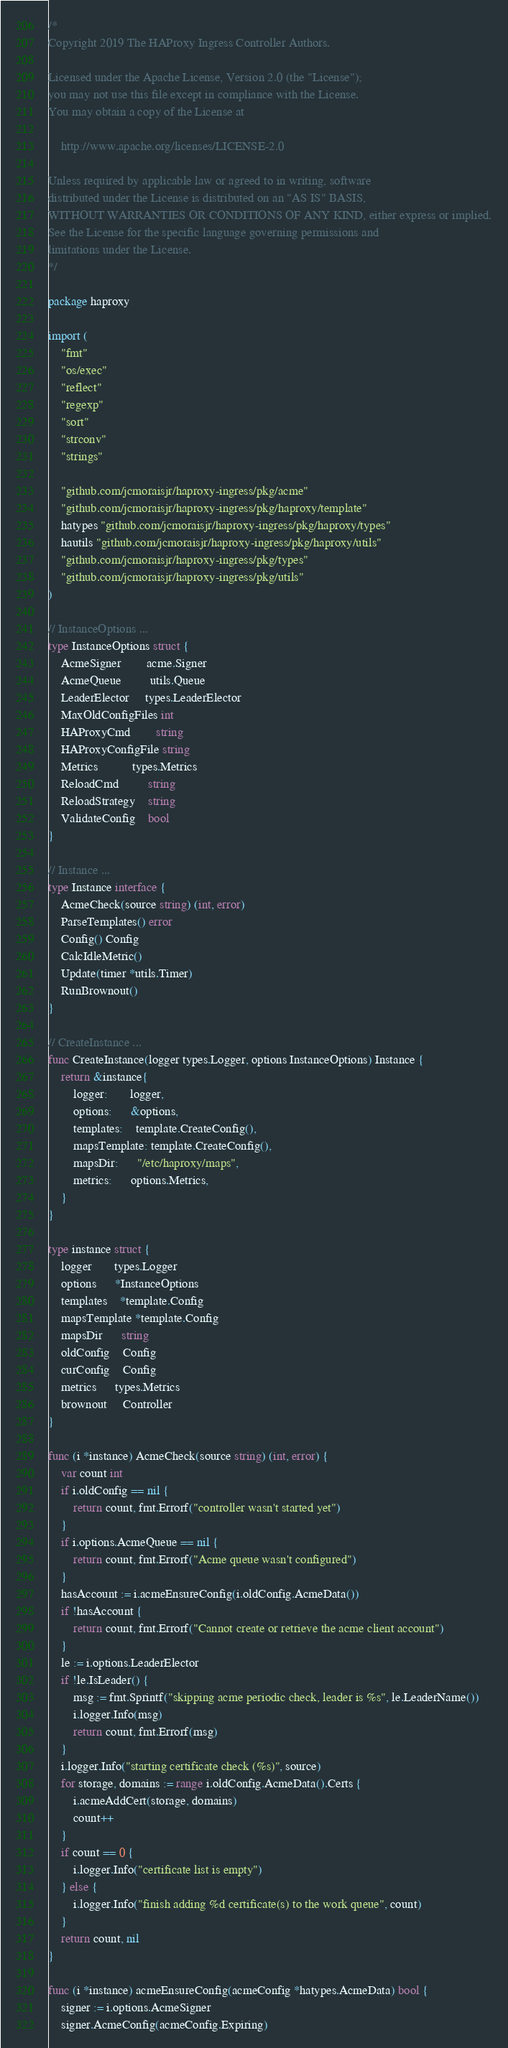Convert code to text. <code><loc_0><loc_0><loc_500><loc_500><_Go_>/*
Copyright 2019 The HAProxy Ingress Controller Authors.

Licensed under the Apache License, Version 2.0 (the "License");
you may not use this file except in compliance with the License.
You may obtain a copy of the License at

    http://www.apache.org/licenses/LICENSE-2.0

Unless required by applicable law or agreed to in writing, software
distributed under the License is distributed on an "AS IS" BASIS,
WITHOUT WARRANTIES OR CONDITIONS OF ANY KIND, either express or implied.
See the License for the specific language governing permissions and
limitations under the License.
*/

package haproxy

import (
	"fmt"
	"os/exec"
	"reflect"
	"regexp"
	"sort"
	"strconv"
	"strings"

	"github.com/jcmoraisjr/haproxy-ingress/pkg/acme"
	"github.com/jcmoraisjr/haproxy-ingress/pkg/haproxy/template"
	hatypes "github.com/jcmoraisjr/haproxy-ingress/pkg/haproxy/types"
	hautils "github.com/jcmoraisjr/haproxy-ingress/pkg/haproxy/utils"
	"github.com/jcmoraisjr/haproxy-ingress/pkg/types"
	"github.com/jcmoraisjr/haproxy-ingress/pkg/utils"
)

// InstanceOptions ...
type InstanceOptions struct {
	AcmeSigner        acme.Signer
	AcmeQueue         utils.Queue
	LeaderElector     types.LeaderElector
	MaxOldConfigFiles int
	HAProxyCmd        string
	HAProxyConfigFile string
	Metrics           types.Metrics
	ReloadCmd         string
	ReloadStrategy    string
	ValidateConfig    bool
}

// Instance ...
type Instance interface {
	AcmeCheck(source string) (int, error)
	ParseTemplates() error
	Config() Config
	CalcIdleMetric()
	Update(timer *utils.Timer)
	RunBrownout()
}

// CreateInstance ...
func CreateInstance(logger types.Logger, options InstanceOptions) Instance {
	return &instance{
		logger:       logger,
		options:      &options,
		templates:    template.CreateConfig(),
		mapsTemplate: template.CreateConfig(),
		mapsDir:      "/etc/haproxy/maps",
		metrics:      options.Metrics,
	}
}

type instance struct {
	logger       types.Logger
	options      *InstanceOptions
	templates    *template.Config
	mapsTemplate *template.Config
	mapsDir      string
	oldConfig    Config
	curConfig    Config
	metrics      types.Metrics
	brownout     Controller
}

func (i *instance) AcmeCheck(source string) (int, error) {
	var count int
	if i.oldConfig == nil {
		return count, fmt.Errorf("controller wasn't started yet")
	}
	if i.options.AcmeQueue == nil {
		return count, fmt.Errorf("Acme queue wasn't configured")
	}
	hasAccount := i.acmeEnsureConfig(i.oldConfig.AcmeData())
	if !hasAccount {
		return count, fmt.Errorf("Cannot create or retrieve the acme client account")
	}
	le := i.options.LeaderElector
	if !le.IsLeader() {
		msg := fmt.Sprintf("skipping acme periodic check, leader is %s", le.LeaderName())
		i.logger.Info(msg)
		return count, fmt.Errorf(msg)
	}
	i.logger.Info("starting certificate check (%s)", source)
	for storage, domains := range i.oldConfig.AcmeData().Certs {
		i.acmeAddCert(storage, domains)
		count++
	}
	if count == 0 {
		i.logger.Info("certificate list is empty")
	} else {
		i.logger.Info("finish adding %d certificate(s) to the work queue", count)
	}
	return count, nil
}

func (i *instance) acmeEnsureConfig(acmeConfig *hatypes.AcmeData) bool {
	signer := i.options.AcmeSigner
	signer.AcmeConfig(acmeConfig.Expiring)</code> 